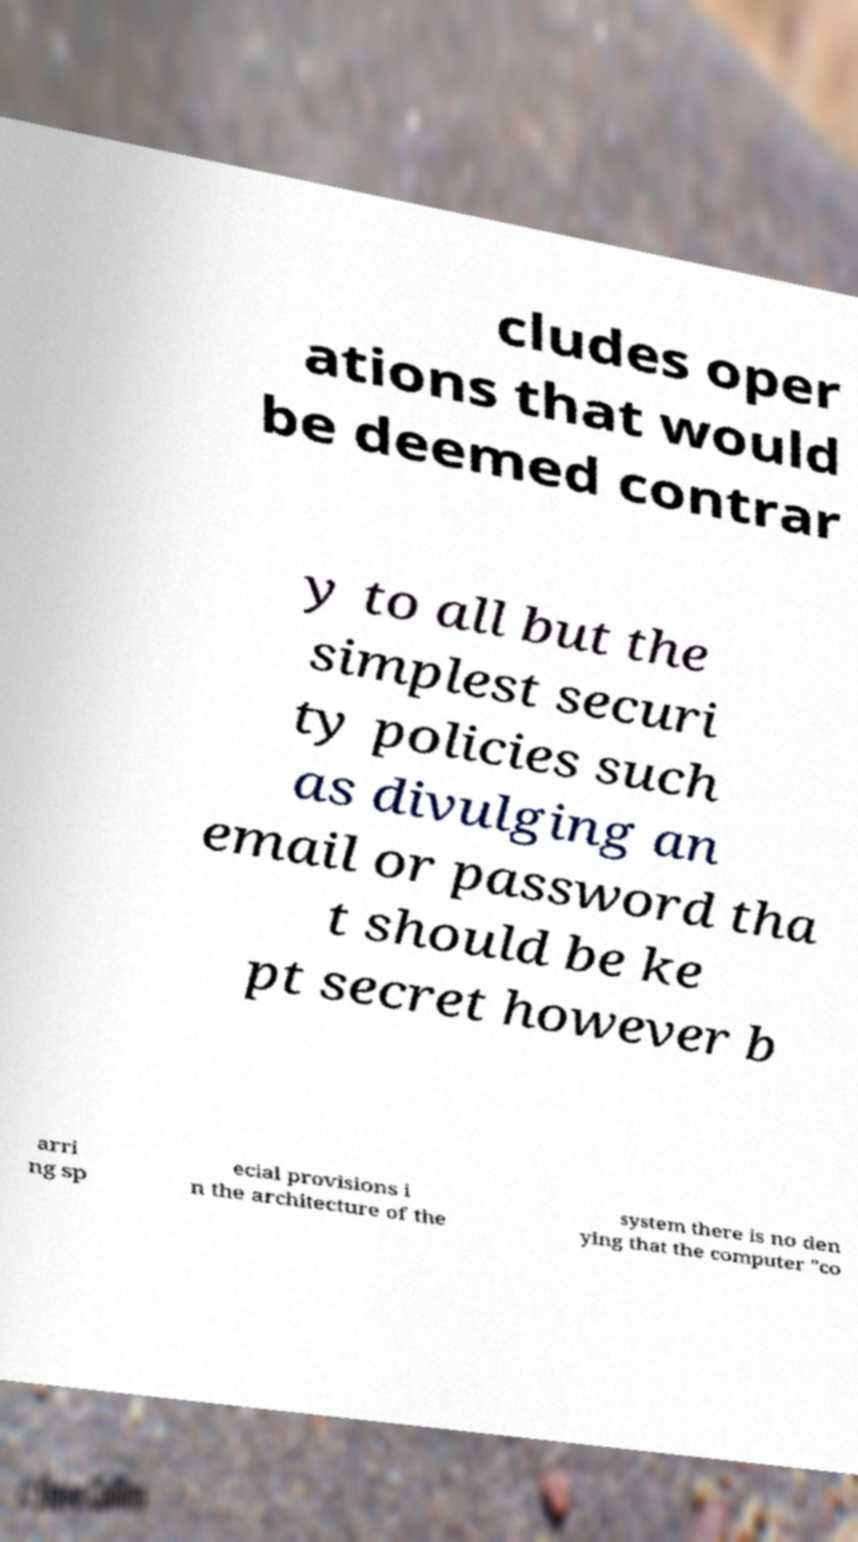There's text embedded in this image that I need extracted. Can you transcribe it verbatim? cludes oper ations that would be deemed contrar y to all but the simplest securi ty policies such as divulging an email or password tha t should be ke pt secret however b arri ng sp ecial provisions i n the architecture of the system there is no den ying that the computer "co 